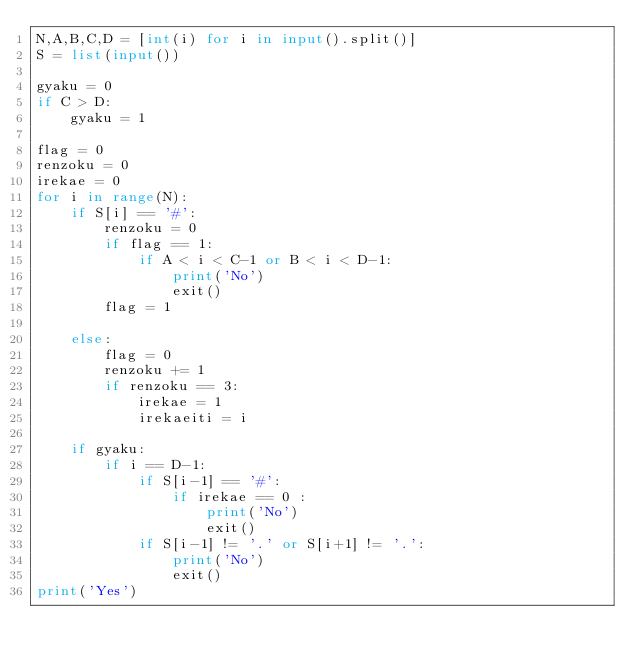<code> <loc_0><loc_0><loc_500><loc_500><_Python_>N,A,B,C,D = [int(i) for i in input().split()]
S = list(input())

gyaku = 0
if C > D:
    gyaku = 1

flag = 0
renzoku = 0
irekae = 0
for i in range(N):
    if S[i] == '#':
        renzoku = 0
        if flag == 1:
            if A < i < C-1 or B < i < D-1:
                print('No')
                exit()
        flag = 1

    else:
        flag = 0
        renzoku += 1
        if renzoku == 3:
            irekae = 1
            irekaeiti = i

    if gyaku:
        if i == D-1:
            if S[i-1] == '#':
                if irekae == 0 :
                    print('No')
                    exit()
            if S[i-1] != '.' or S[i+1] != '.':
                print('No')
                exit()
print('Yes')
</code> 